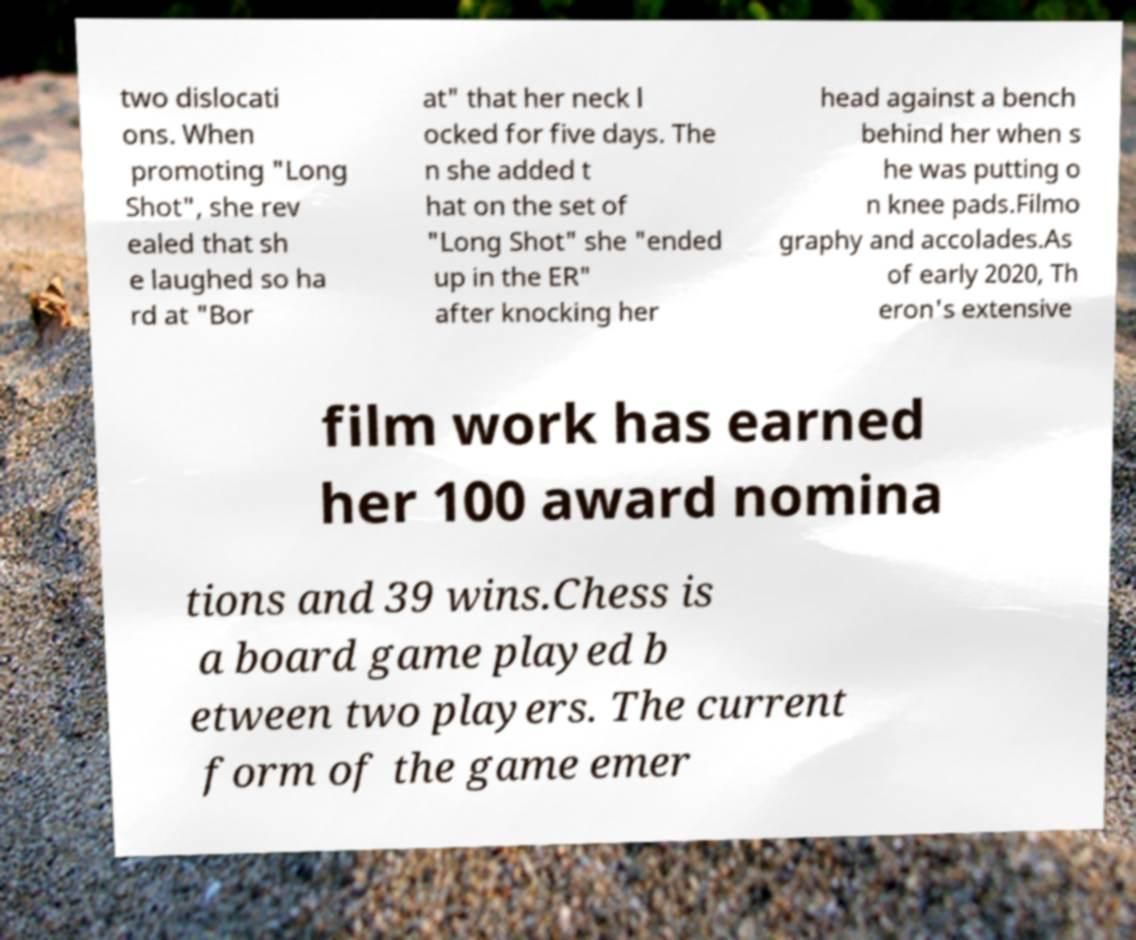Can you read and provide the text displayed in the image?This photo seems to have some interesting text. Can you extract and type it out for me? two dislocati ons. When promoting "Long Shot", she rev ealed that sh e laughed so ha rd at "Bor at" that her neck l ocked for five days. The n she added t hat on the set of "Long Shot" she "ended up in the ER" after knocking her head against a bench behind her when s he was putting o n knee pads.Filmo graphy and accolades.As of early 2020, Th eron's extensive film work has earned her 100 award nomina tions and 39 wins.Chess is a board game played b etween two players. The current form of the game emer 